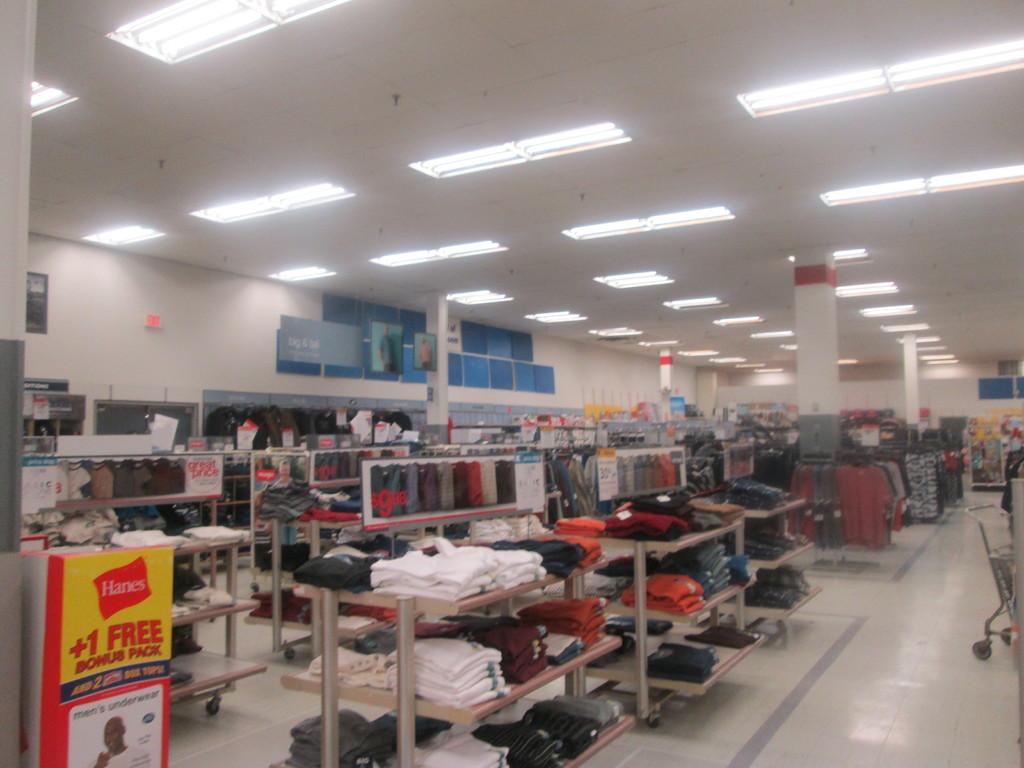How many hanes shirts can i get as a bonus?
Your answer should be compact. 1. What are the words above the man's head on the ad on the bottom left?
Make the answer very short. Men's underwear. 